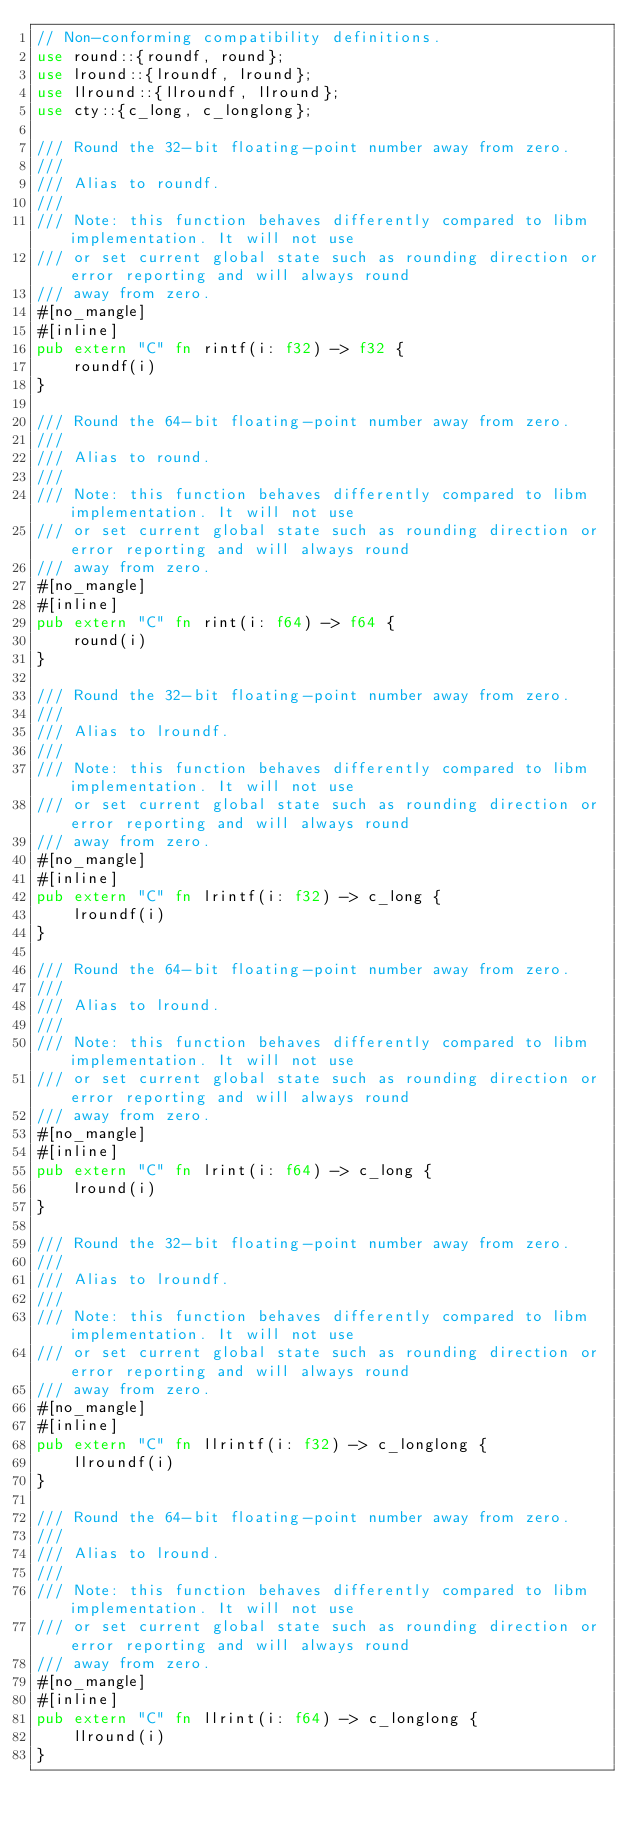Convert code to text. <code><loc_0><loc_0><loc_500><loc_500><_Rust_>// Non-conforming compatibility definitions.
use round::{roundf, round};
use lround::{lroundf, lround};
use llround::{llroundf, llround};
use cty::{c_long, c_longlong};

/// Round the 32-bit floating-point number away from zero.
///
/// Alias to roundf.
///
/// Note: this function behaves differently compared to libm implementation. It will not use
/// or set current global state such as rounding direction or error reporting and will always round
/// away from zero.
#[no_mangle]
#[inline]
pub extern "C" fn rintf(i: f32) -> f32 {
    roundf(i)
}

/// Round the 64-bit floating-point number away from zero.
///
/// Alias to round.
///
/// Note: this function behaves differently compared to libm implementation. It will not use
/// or set current global state such as rounding direction or error reporting and will always round
/// away from zero.
#[no_mangle]
#[inline]
pub extern "C" fn rint(i: f64) -> f64 {
    round(i)
}

/// Round the 32-bit floating-point number away from zero.
///
/// Alias to lroundf.
///
/// Note: this function behaves differently compared to libm implementation. It will not use
/// or set current global state such as rounding direction or error reporting and will always round
/// away from zero.
#[no_mangle]
#[inline]
pub extern "C" fn lrintf(i: f32) -> c_long {
    lroundf(i)
}

/// Round the 64-bit floating-point number away from zero.
///
/// Alias to lround.
///
/// Note: this function behaves differently compared to libm implementation. It will not use
/// or set current global state such as rounding direction or error reporting and will always round
/// away from zero.
#[no_mangle]
#[inline]
pub extern "C" fn lrint(i: f64) -> c_long {
    lround(i)
}

/// Round the 32-bit floating-point number away from zero.
///
/// Alias to lroundf.
///
/// Note: this function behaves differently compared to libm implementation. It will not use
/// or set current global state such as rounding direction or error reporting and will always round
/// away from zero.
#[no_mangle]
#[inline]
pub extern "C" fn llrintf(i: f32) -> c_longlong {
    llroundf(i)
}

/// Round the 64-bit floating-point number away from zero.
///
/// Alias to lround.
///
/// Note: this function behaves differently compared to libm implementation. It will not use
/// or set current global state such as rounding direction or error reporting and will always round
/// away from zero.
#[no_mangle]
#[inline]
pub extern "C" fn llrint(i: f64) -> c_longlong {
    llround(i)
}
</code> 